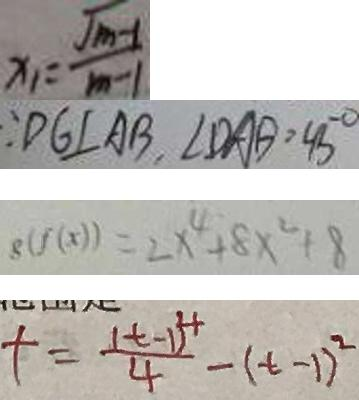<formula> <loc_0><loc_0><loc_500><loc_500>x _ { 1 } = \frac { \sqrt { m - 1 } } { m - 1 } 
 \because D G \bot A B , \angle D A B = 4 5 ^ { \circ } 
 \delta ( f ( x ) ) = 2 x ^ { 4 } + 8 x ^ { 2 } + 8 
 t = \frac { ( t - 1 ) ^ { 4 } } { 4 } - ( t - 1 ) ^ { 2 }</formula> 